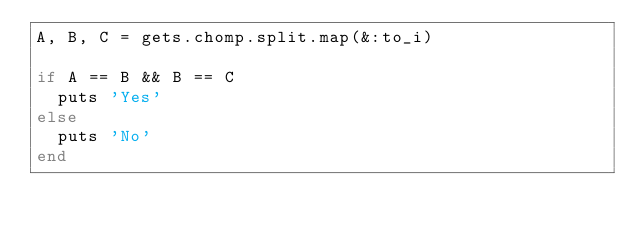<code> <loc_0><loc_0><loc_500><loc_500><_Ruby_>A, B, C = gets.chomp.split.map(&:to_i)

if A == B && B == C
  puts 'Yes'
else
  puts 'No'
end
</code> 